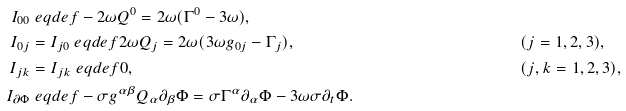Convert formula to latex. <formula><loc_0><loc_0><loc_500><loc_500>I _ { 0 0 } & \ e q d e f - 2 \omega Q ^ { 0 } = 2 \omega ( \Gamma ^ { 0 } - 3 \omega ) , \\ I _ { 0 j } & = I _ { j 0 } \ e q d e f 2 \omega Q _ { j } = 2 \omega ( 3 \omega g _ { 0 j } - \Gamma _ { j } ) , & & ( j = 1 , 2 , 3 ) , \\ I _ { j k } & = I _ { j k } \ e q d e f 0 , & & ( j , k = 1 , 2 , 3 ) , \\ I _ { \partial \Phi } & \ e q d e f - \sigma g ^ { \alpha \beta } Q _ { \alpha } \partial _ { \beta } \Phi = \sigma \Gamma ^ { \alpha } \partial _ { \alpha } \Phi - 3 \omega \sigma \partial _ { t } \Phi .</formula> 